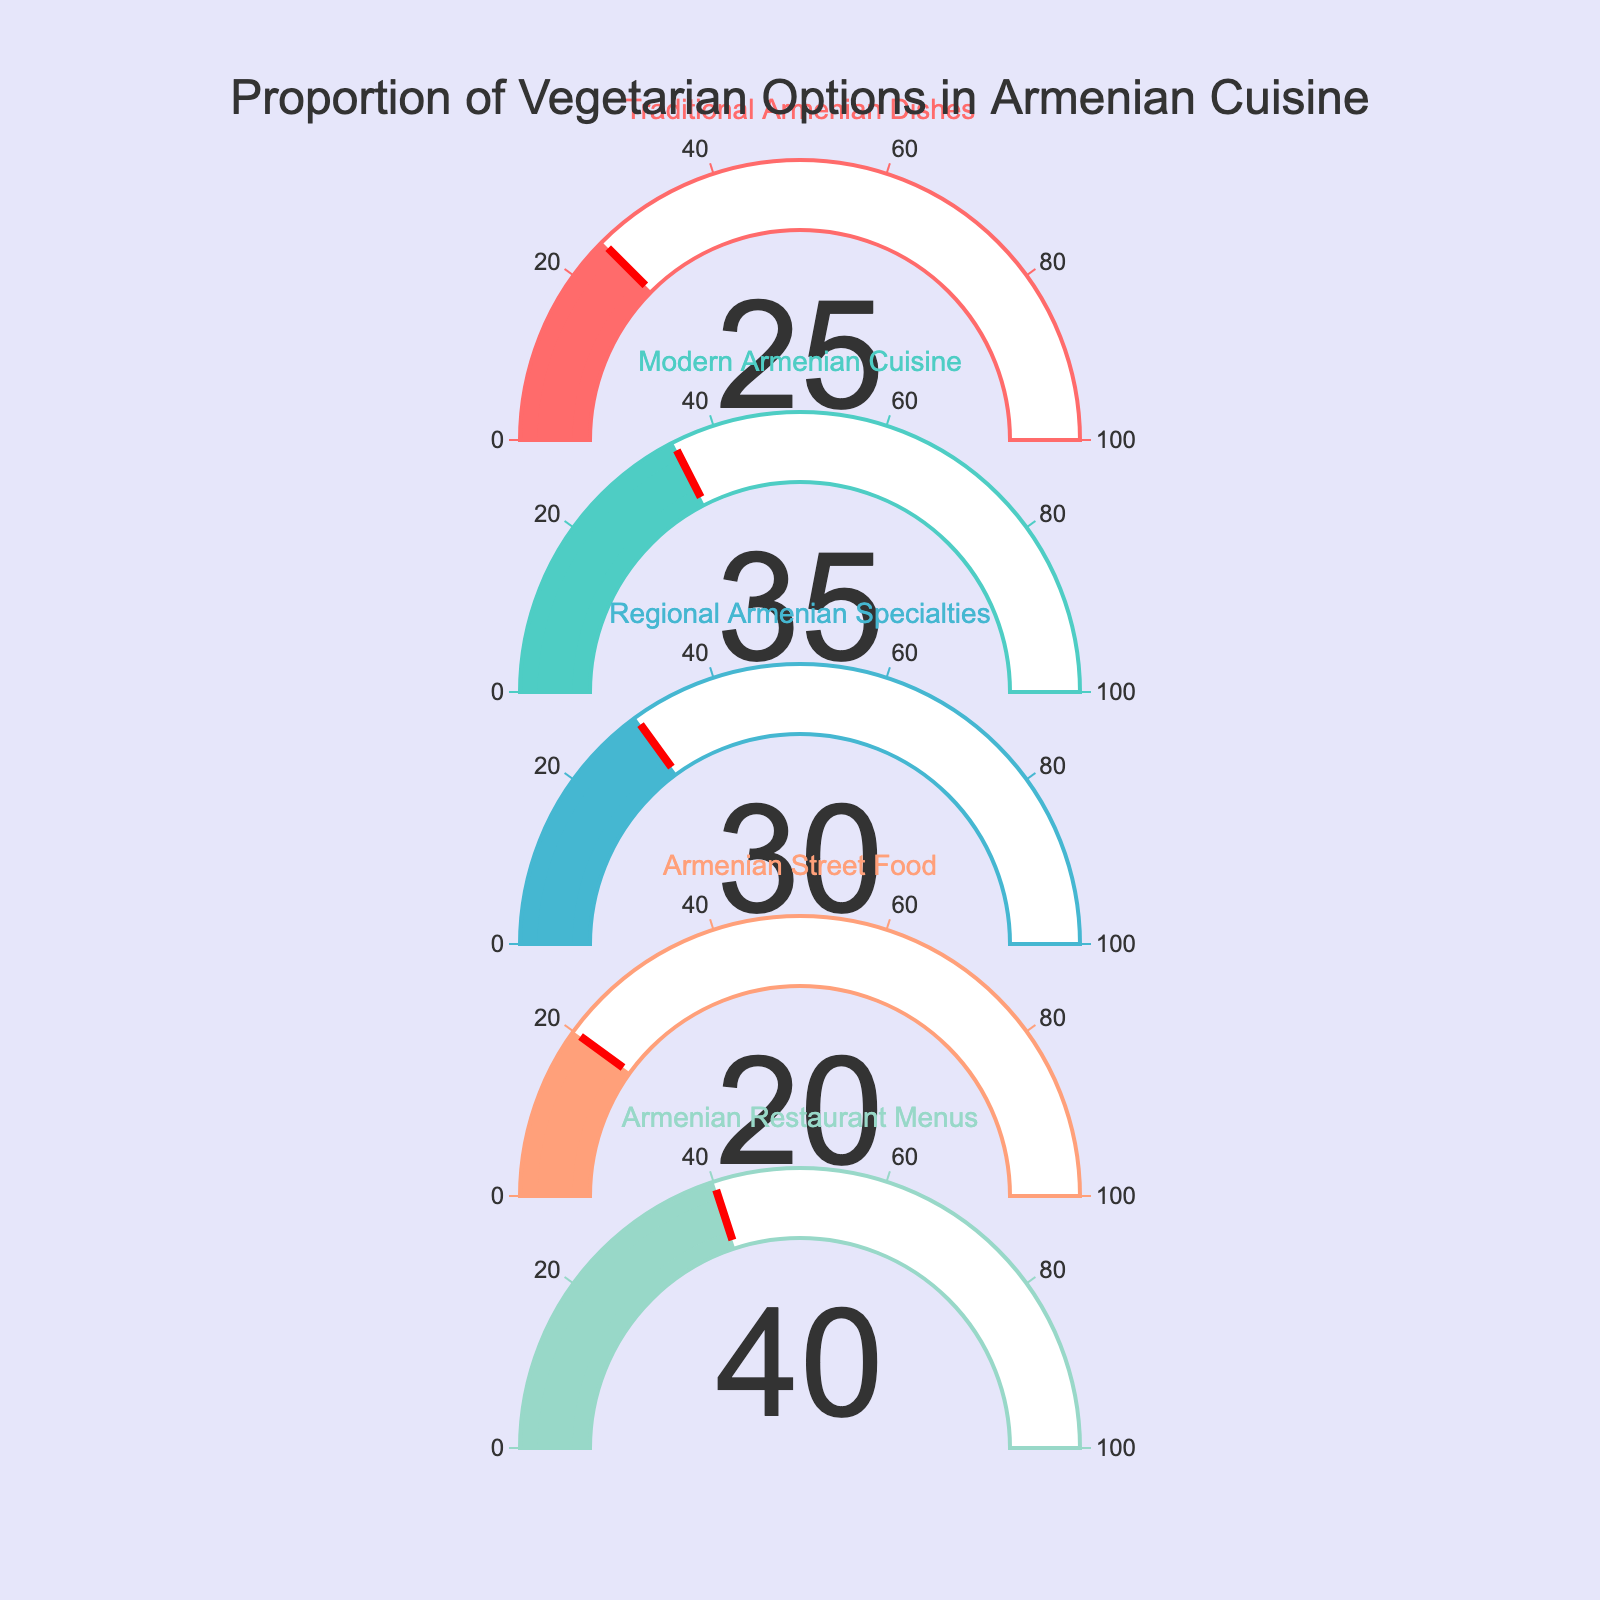What's the title of this figure? The figure title is usually located at the top of the chart, in this case, it states: "Proportion of Vegetarian Options in Armenian Cuisine"
Answer: Proportion of Vegetarian Options in Armenian Cuisine How many categories of Armenian cuisine are displayed in the figure? Count the number of different gauge charts shown in the figure. There are five separate gauges, each representing a different category.
Answer: 5 Which category has the highest proportion of vegetarian options? Look at the value displayed on each gauge. The highest number is on the gauge for "Armenian Restaurant Menus" with 40%.
Answer: Armenian Restaurant Menus What is the sum of the proportions of vegetarian options in Traditional Armenian Dishes and Armenian Street Food? Add the percentages from Traditional Armenian Dishes (25%) and Armenian Street Food (20%). The result is 25 + 20 = 45%.
Answer: 45% Which category has a proportion of vegetarian options that is less than 30%? Identify categories with percentages below 30%: Traditional Armenian Dishes (25%) and Armenian Street Food (20%).
Answer: Traditional Armenian Dishes, Armenian Street Food What is the average proportion of vegetarian options across all categories? Sum all the displayed percentages and divide by the number of categories: (25 + 35 + 30 + 20 + 40) / 5 = 150 / 5 = 30%.
Answer: 30% How much higher is the proportion of vegetarian options in Modern Armenian Cuisine compared to Armenian Street Food? Subtract the percentage of Armenian Street Food (20%) from Modern Armenian Cuisine (35%): 35% - 20% = 15%.
Answer: 15% Which category has a proportion of vegetarian options closest to the average proportion across all categories? The average is 30%. Check which category has a percentage closest to 30%. Both Modern Armenian Cuisine (35%) and Regional Armenian Specialties (30%) are close, with Regional Armenian Specialties being exactly 30%.
Answer: Regional Armenian Specialties Do any categories have exactly 35% as their proportion of vegetarian options? Look at the gauges. The category "Modern Armenian Cuisine" has exactly 35%.
Answer: Modern Armenian Cuisine Which two categories have the smallest difference in their proportions of vegetarian options? Calculate the differences between all pairs: Traditional Armenian Dishes (25%) and Regional Armenian Specialties (30%) have a difference of 5%, which is the smallest difference.
Answer: Traditional Armenian Dishes and Regional Armenian Specialties 